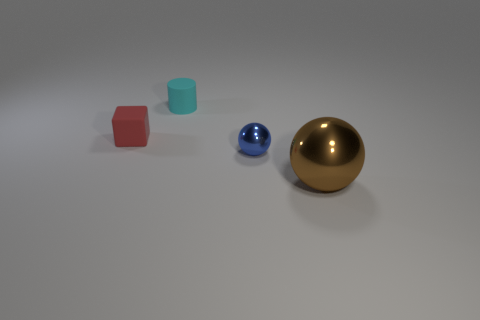Add 4 yellow metallic blocks. How many objects exist? 8 Subtract all cylinders. How many objects are left? 3 Add 3 large brown metallic objects. How many large brown metallic objects are left? 4 Add 4 tiny metallic spheres. How many tiny metallic spheres exist? 5 Subtract 0 purple cylinders. How many objects are left? 4 Subtract all big brown metal cylinders. Subtract all tiny rubber objects. How many objects are left? 2 